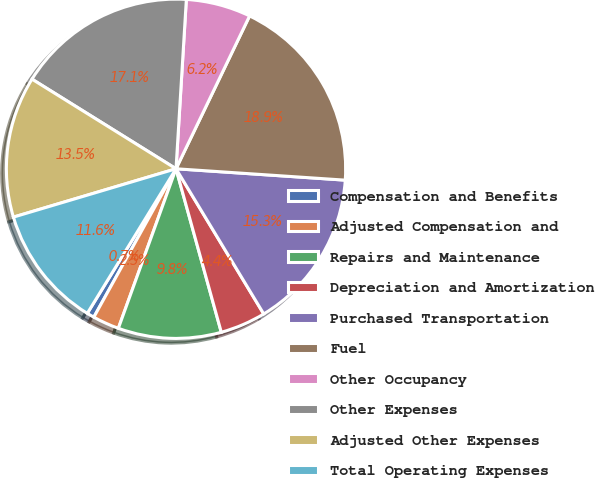Convert chart. <chart><loc_0><loc_0><loc_500><loc_500><pie_chart><fcel>Compensation and Benefits<fcel>Adjusted Compensation and<fcel>Repairs and Maintenance<fcel>Depreciation and Amortization<fcel>Purchased Transportation<fcel>Fuel<fcel>Other Occupancy<fcel>Other Expenses<fcel>Adjusted Other Expenses<fcel>Total Operating Expenses<nl><fcel>0.71%<fcel>2.53%<fcel>9.82%<fcel>4.35%<fcel>15.28%<fcel>18.93%<fcel>6.17%<fcel>17.11%<fcel>13.46%<fcel>11.64%<nl></chart> 